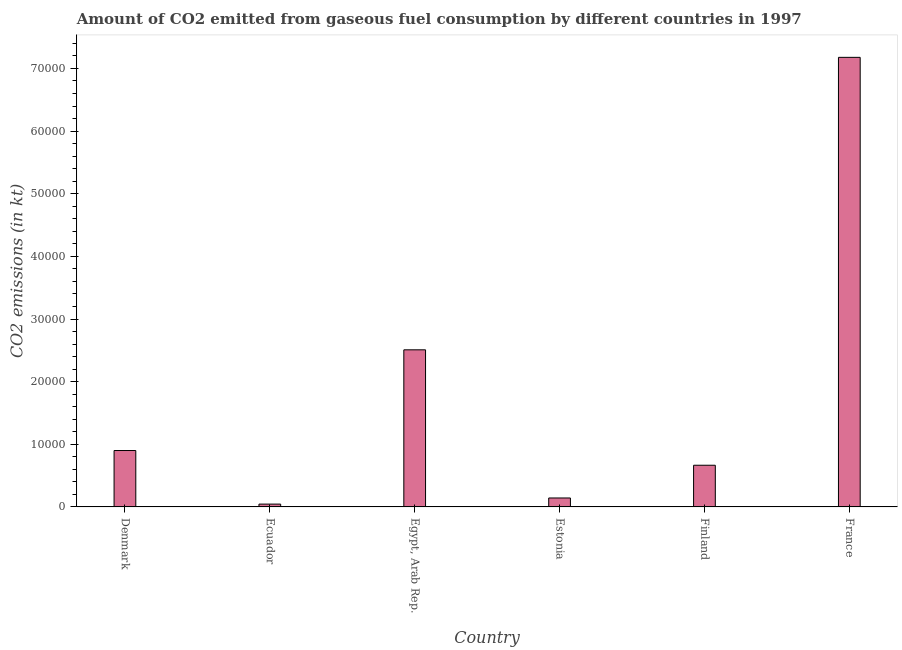Does the graph contain any zero values?
Keep it short and to the point. No. What is the title of the graph?
Provide a short and direct response. Amount of CO2 emitted from gaseous fuel consumption by different countries in 1997. What is the label or title of the X-axis?
Give a very brief answer. Country. What is the label or title of the Y-axis?
Provide a short and direct response. CO2 emissions (in kt). What is the co2 emissions from gaseous fuel consumption in France?
Keep it short and to the point. 7.18e+04. Across all countries, what is the maximum co2 emissions from gaseous fuel consumption?
Offer a very short reply. 7.18e+04. Across all countries, what is the minimum co2 emissions from gaseous fuel consumption?
Your answer should be compact. 451.04. In which country was the co2 emissions from gaseous fuel consumption minimum?
Your answer should be very brief. Ecuador. What is the sum of the co2 emissions from gaseous fuel consumption?
Make the answer very short. 1.14e+05. What is the difference between the co2 emissions from gaseous fuel consumption in Egypt, Arab Rep. and Estonia?
Offer a very short reply. 2.37e+04. What is the average co2 emissions from gaseous fuel consumption per country?
Your answer should be very brief. 1.91e+04. What is the median co2 emissions from gaseous fuel consumption?
Offer a very short reply. 7830.88. In how many countries, is the co2 emissions from gaseous fuel consumption greater than 58000 kt?
Provide a short and direct response. 1. What is the ratio of the co2 emissions from gaseous fuel consumption in Egypt, Arab Rep. to that in Finland?
Give a very brief answer. 3.77. Is the difference between the co2 emissions from gaseous fuel consumption in Egypt, Arab Rep. and Finland greater than the difference between any two countries?
Your answer should be compact. No. What is the difference between the highest and the second highest co2 emissions from gaseous fuel consumption?
Give a very brief answer. 4.67e+04. What is the difference between the highest and the lowest co2 emissions from gaseous fuel consumption?
Keep it short and to the point. 7.13e+04. In how many countries, is the co2 emissions from gaseous fuel consumption greater than the average co2 emissions from gaseous fuel consumption taken over all countries?
Ensure brevity in your answer.  2. What is the CO2 emissions (in kt) of Denmark?
Your response must be concise. 9006.15. What is the CO2 emissions (in kt) of Ecuador?
Offer a terse response. 451.04. What is the CO2 emissions (in kt) in Egypt, Arab Rep.?
Give a very brief answer. 2.51e+04. What is the CO2 emissions (in kt) in Estonia?
Provide a succinct answer. 1430.13. What is the CO2 emissions (in kt) of Finland?
Provide a short and direct response. 6655.6. What is the CO2 emissions (in kt) of France?
Offer a very short reply. 7.18e+04. What is the difference between the CO2 emissions (in kt) in Denmark and Ecuador?
Your answer should be very brief. 8555.11. What is the difference between the CO2 emissions (in kt) in Denmark and Egypt, Arab Rep.?
Your response must be concise. -1.61e+04. What is the difference between the CO2 emissions (in kt) in Denmark and Estonia?
Your response must be concise. 7576.02. What is the difference between the CO2 emissions (in kt) in Denmark and Finland?
Keep it short and to the point. 2350.55. What is the difference between the CO2 emissions (in kt) in Denmark and France?
Provide a short and direct response. -6.28e+04. What is the difference between the CO2 emissions (in kt) in Ecuador and Egypt, Arab Rep.?
Your answer should be compact. -2.46e+04. What is the difference between the CO2 emissions (in kt) in Ecuador and Estonia?
Provide a short and direct response. -979.09. What is the difference between the CO2 emissions (in kt) in Ecuador and Finland?
Make the answer very short. -6204.56. What is the difference between the CO2 emissions (in kt) in Ecuador and France?
Give a very brief answer. -7.13e+04. What is the difference between the CO2 emissions (in kt) in Egypt, Arab Rep. and Estonia?
Make the answer very short. 2.37e+04. What is the difference between the CO2 emissions (in kt) in Egypt, Arab Rep. and Finland?
Your response must be concise. 1.84e+04. What is the difference between the CO2 emissions (in kt) in Egypt, Arab Rep. and France?
Your answer should be very brief. -4.67e+04. What is the difference between the CO2 emissions (in kt) in Estonia and Finland?
Provide a short and direct response. -5225.48. What is the difference between the CO2 emissions (in kt) in Estonia and France?
Make the answer very short. -7.03e+04. What is the difference between the CO2 emissions (in kt) in Finland and France?
Your answer should be compact. -6.51e+04. What is the ratio of the CO2 emissions (in kt) in Denmark to that in Ecuador?
Give a very brief answer. 19.97. What is the ratio of the CO2 emissions (in kt) in Denmark to that in Egypt, Arab Rep.?
Provide a succinct answer. 0.36. What is the ratio of the CO2 emissions (in kt) in Denmark to that in Estonia?
Make the answer very short. 6.3. What is the ratio of the CO2 emissions (in kt) in Denmark to that in Finland?
Keep it short and to the point. 1.35. What is the ratio of the CO2 emissions (in kt) in Ecuador to that in Egypt, Arab Rep.?
Make the answer very short. 0.02. What is the ratio of the CO2 emissions (in kt) in Ecuador to that in Estonia?
Make the answer very short. 0.32. What is the ratio of the CO2 emissions (in kt) in Ecuador to that in Finland?
Your answer should be compact. 0.07. What is the ratio of the CO2 emissions (in kt) in Ecuador to that in France?
Offer a terse response. 0.01. What is the ratio of the CO2 emissions (in kt) in Egypt, Arab Rep. to that in Estonia?
Your response must be concise. 17.54. What is the ratio of the CO2 emissions (in kt) in Egypt, Arab Rep. to that in Finland?
Give a very brief answer. 3.77. What is the ratio of the CO2 emissions (in kt) in Egypt, Arab Rep. to that in France?
Ensure brevity in your answer.  0.35. What is the ratio of the CO2 emissions (in kt) in Estonia to that in Finland?
Keep it short and to the point. 0.21. What is the ratio of the CO2 emissions (in kt) in Finland to that in France?
Make the answer very short. 0.09. 